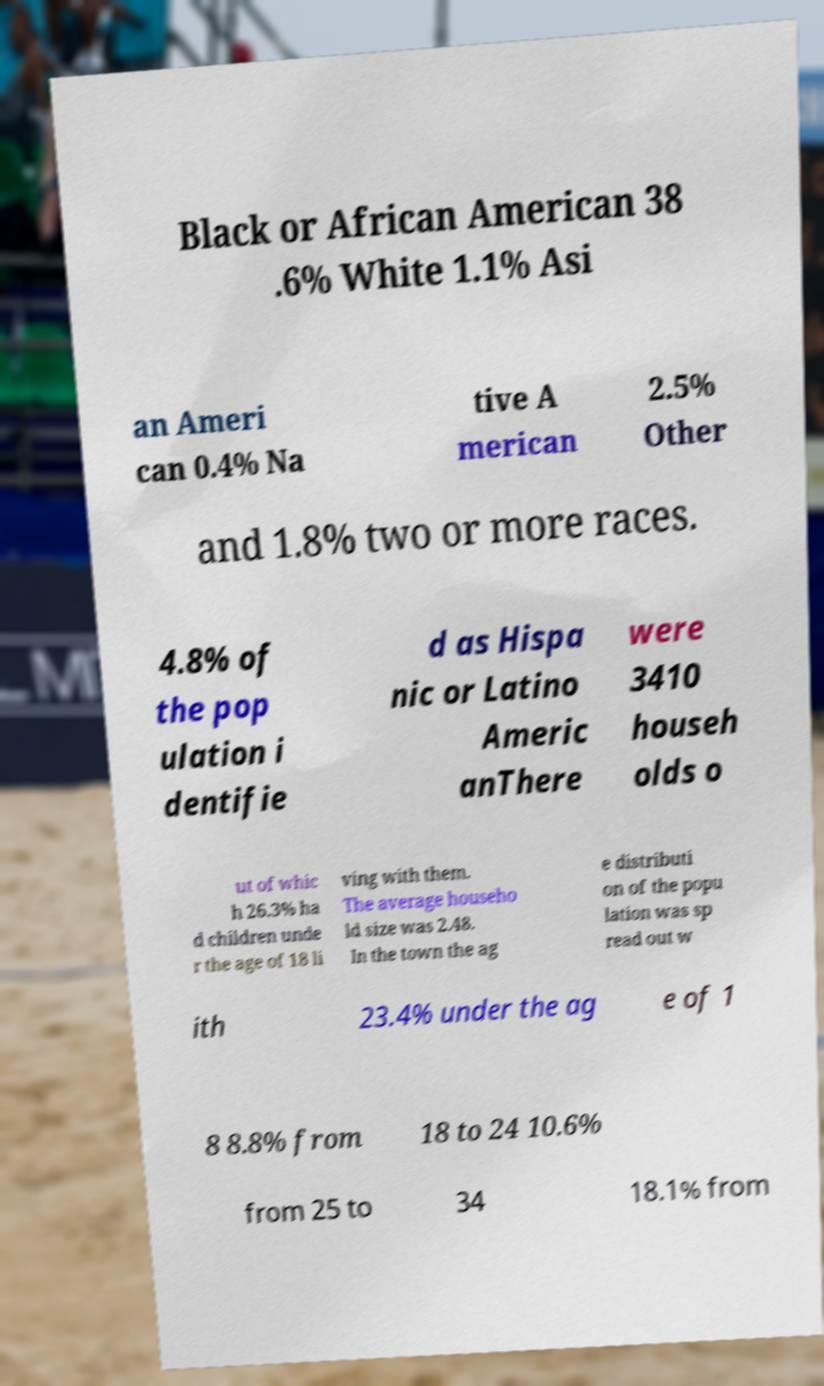Can you accurately transcribe the text from the provided image for me? Black or African American 38 .6% White 1.1% Asi an Ameri can 0.4% Na tive A merican 2.5% Other and 1.8% two or more races. 4.8% of the pop ulation i dentifie d as Hispa nic or Latino Americ anThere were 3410 househ olds o ut of whic h 26.3% ha d children unde r the age of 18 li ving with them. The average househo ld size was 2.48. In the town the ag e distributi on of the popu lation was sp read out w ith 23.4% under the ag e of 1 8 8.8% from 18 to 24 10.6% from 25 to 34 18.1% from 